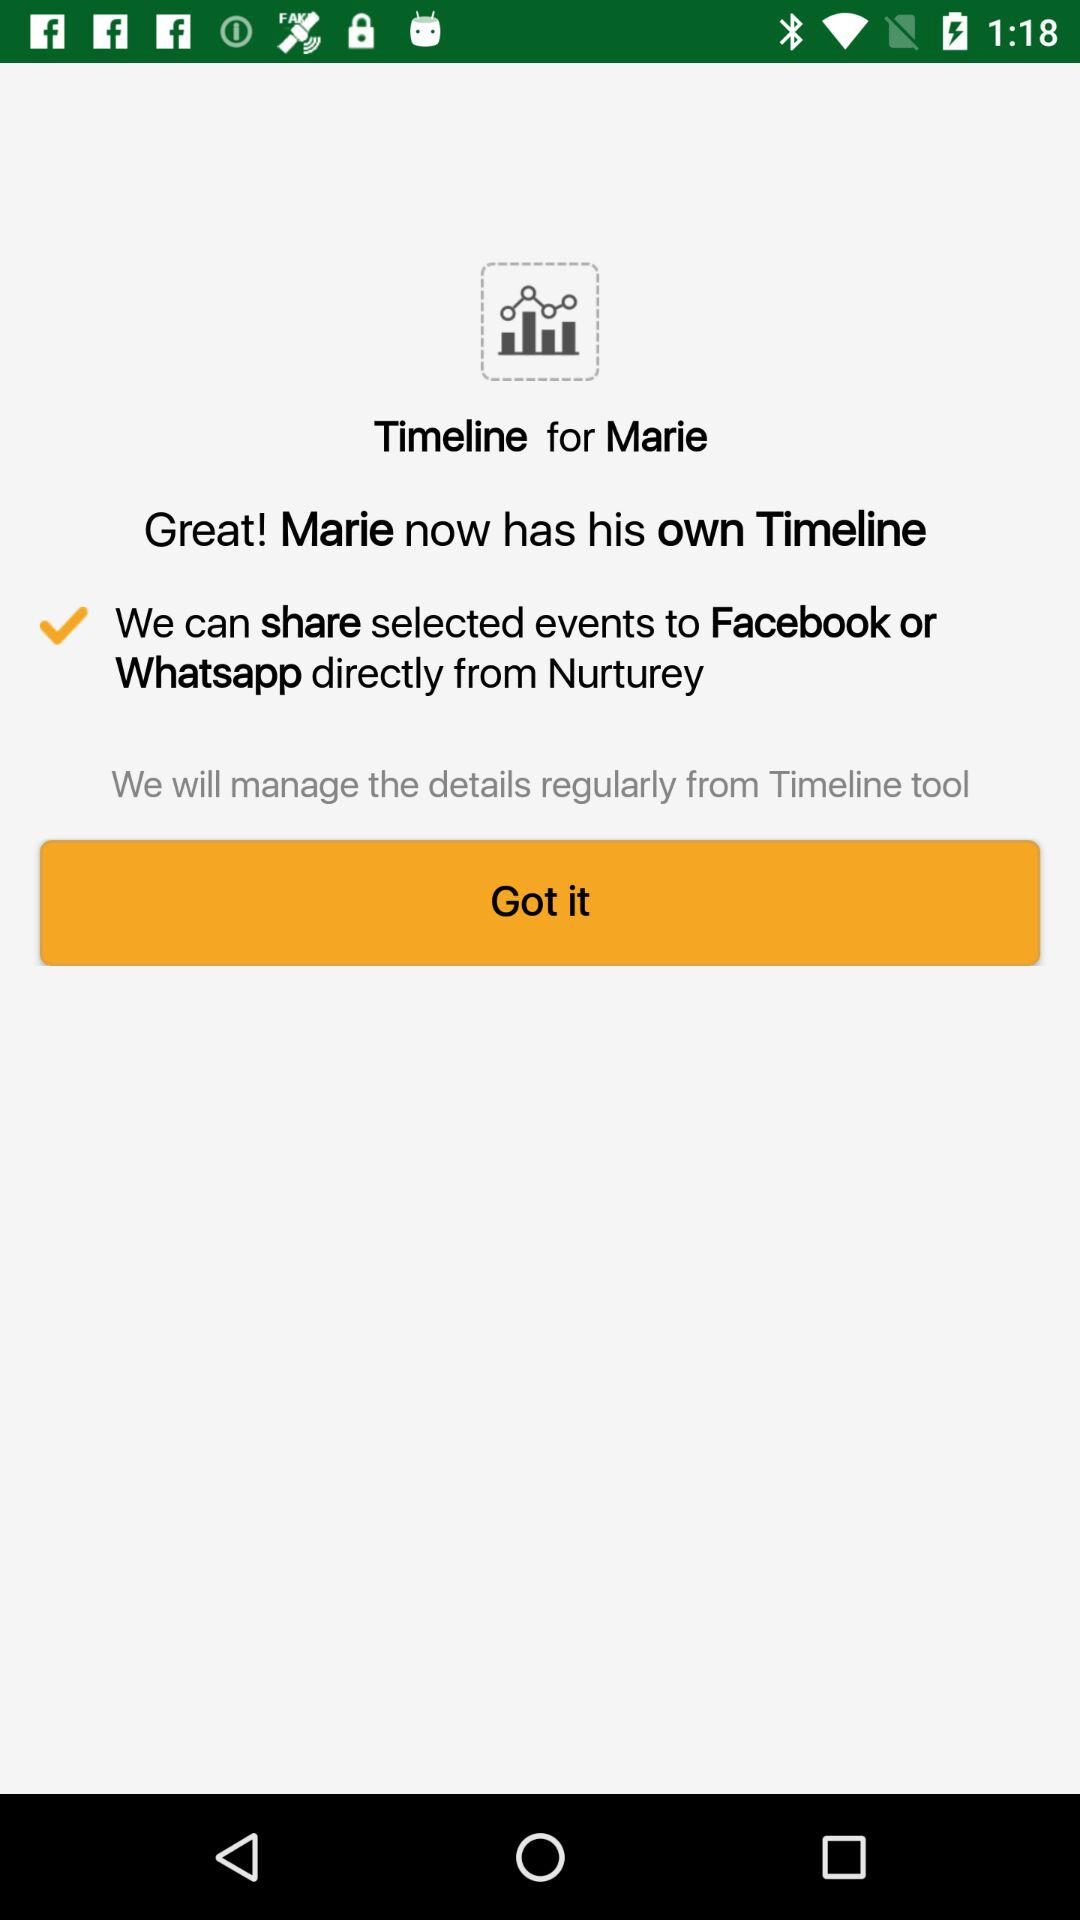What is the name of the user? The name of the user is Marie. 